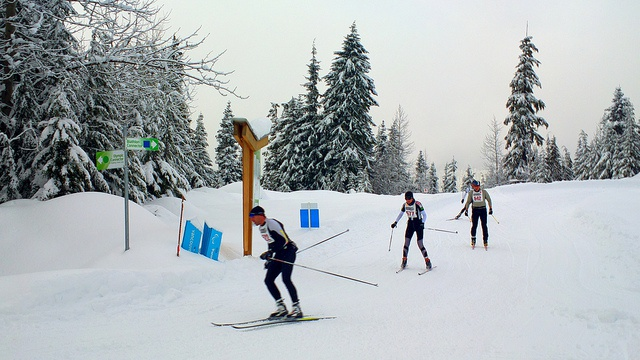Describe the objects in this image and their specific colors. I can see people in gray, black, darkgray, and maroon tones, people in gray, black, darkgray, and lightgray tones, people in gray, black, darkgray, and lightblue tones, skis in gray, lightgray, and darkgray tones, and people in gray, darkgray, and lightgray tones in this image. 